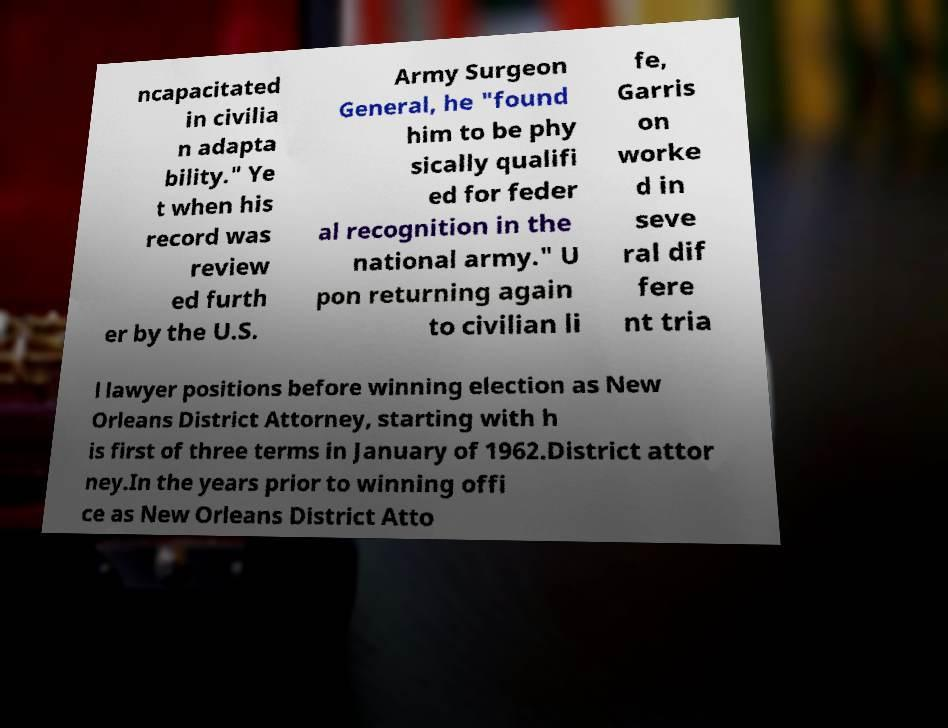Please read and relay the text visible in this image. What does it say? ncapacitated in civilia n adapta bility." Ye t when his record was review ed furth er by the U.S. Army Surgeon General, he "found him to be phy sically qualifi ed for feder al recognition in the national army." U pon returning again to civilian li fe, Garris on worke d in seve ral dif fere nt tria l lawyer positions before winning election as New Orleans District Attorney, starting with h is first of three terms in January of 1962.District attor ney.In the years prior to winning offi ce as New Orleans District Atto 